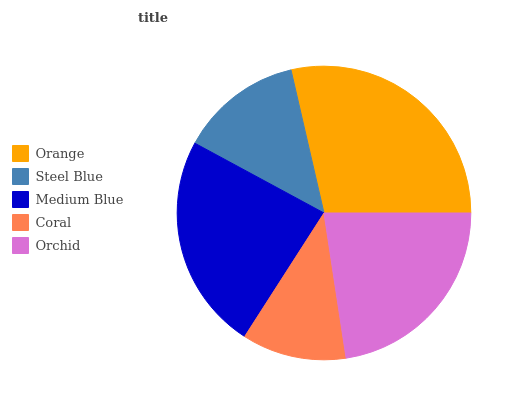Is Coral the minimum?
Answer yes or no. Yes. Is Orange the maximum?
Answer yes or no. Yes. Is Steel Blue the minimum?
Answer yes or no. No. Is Steel Blue the maximum?
Answer yes or no. No. Is Orange greater than Steel Blue?
Answer yes or no. Yes. Is Steel Blue less than Orange?
Answer yes or no. Yes. Is Steel Blue greater than Orange?
Answer yes or no. No. Is Orange less than Steel Blue?
Answer yes or no. No. Is Orchid the high median?
Answer yes or no. Yes. Is Orchid the low median?
Answer yes or no. Yes. Is Coral the high median?
Answer yes or no. No. Is Coral the low median?
Answer yes or no. No. 